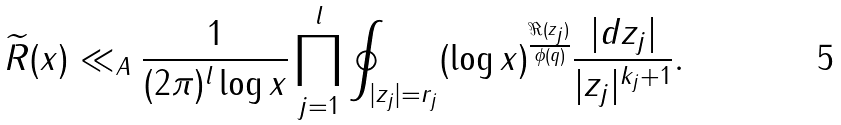Convert formula to latex. <formula><loc_0><loc_0><loc_500><loc_500>\widetilde { R } ( x ) \ll _ { A } \frac { 1 } { ( 2 \pi ) ^ { l } \log x } \prod _ { j = 1 } ^ { l } \oint _ { | z _ { j } | = r _ { j } } ( \log x ) ^ { \frac { \Re ( z _ { j } ) } { \phi ( q ) } } \frac { | d z _ { j } | } { | z _ { j } | ^ { k _ { j } + 1 } } .</formula> 